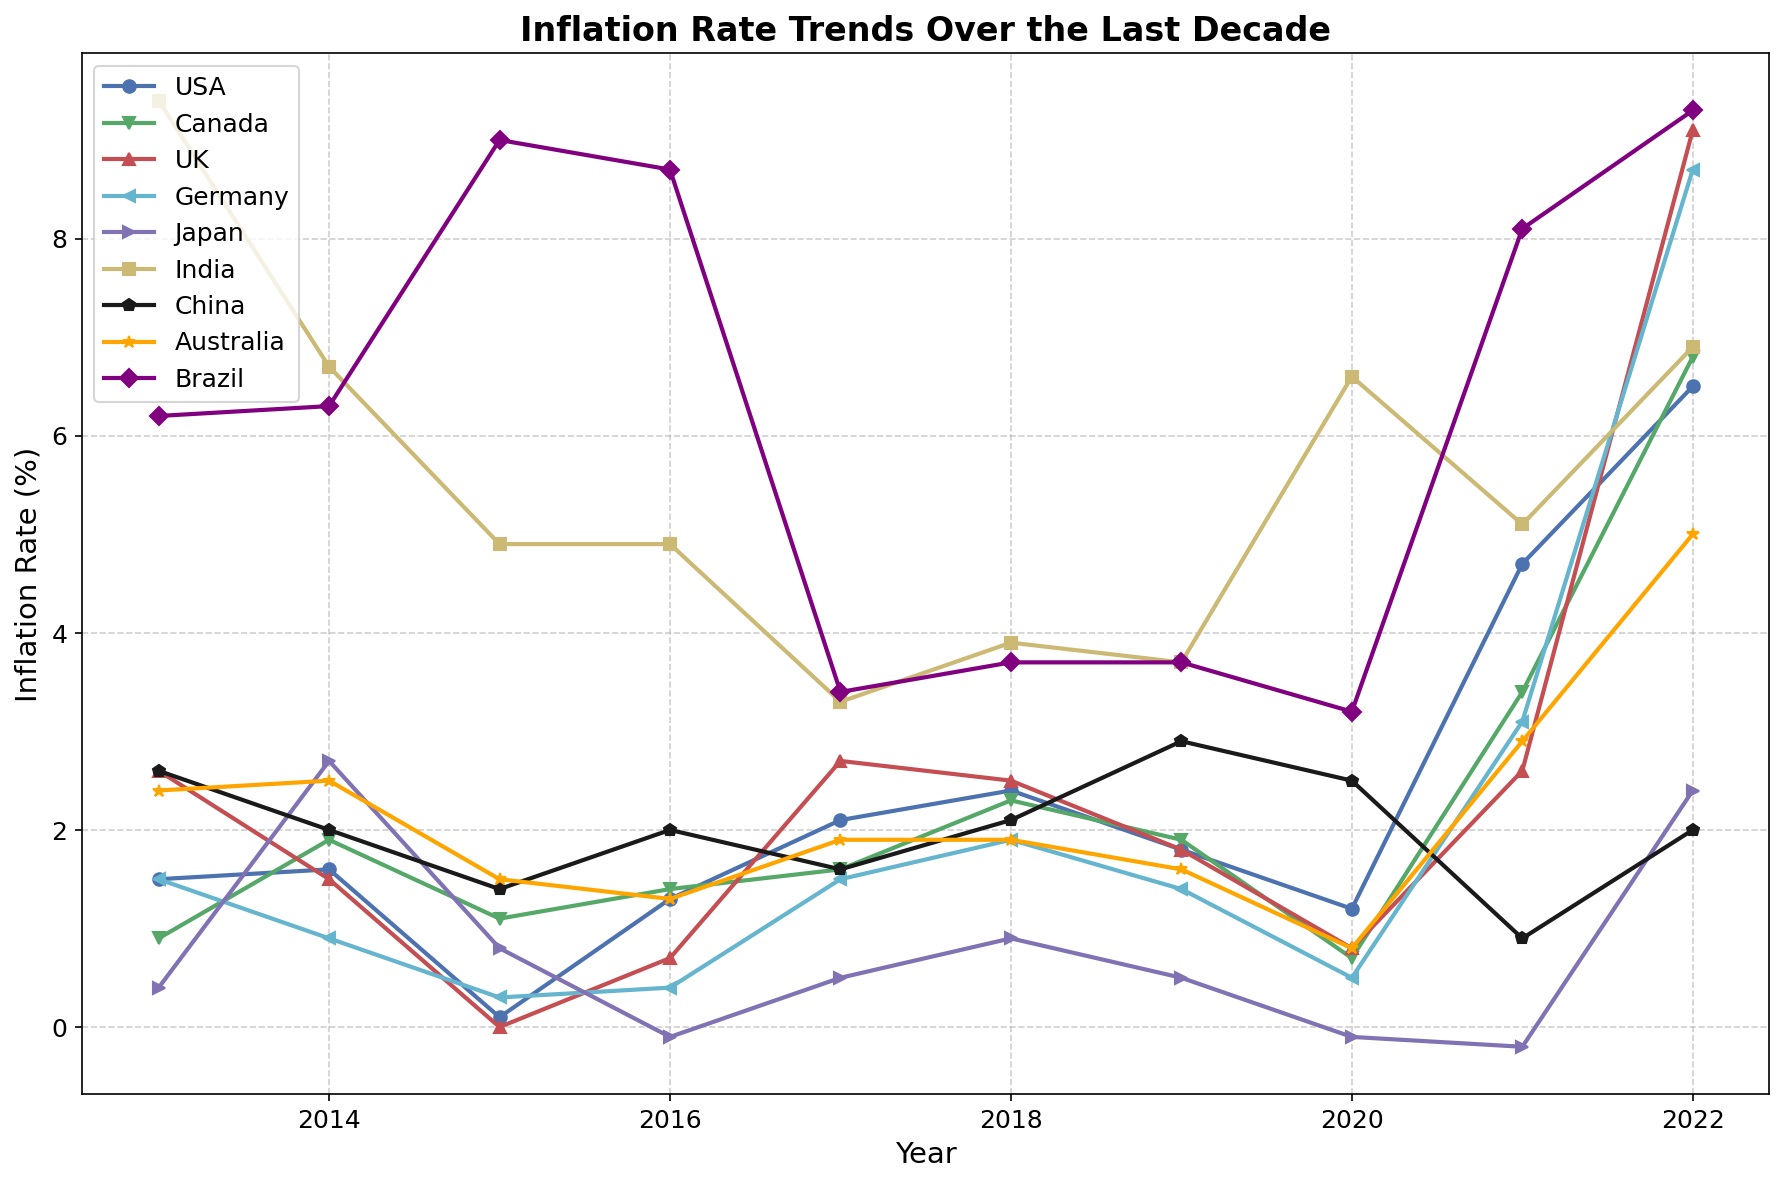What was the inflation rate of Germany in 2022? We look at the plot for the year 2022 and identify the line color and marker style representing Germany to find the value at that point.
Answer: 8.7% Which country experienced the highest inflation rate in 2022? Check the lines on the plot for 2022 and identify which country has the highest data point.
Answer: Brazil Between 2015 and 2016, what was the change in inflation rate for the UK? Identify the points corresponding to the UK for the years 2015 and 2016 and calculate their difference: 0.7 (2016) - 0.0 (2015)
Answer: 0.7% Which country saw a decrease in inflation rate between 2014 and 2015? Compare the values from 2014 to 2015 for each country and find which one decreased.
Answer: India What is the average inflation rate of Japan from 2013 to 2022? Sum up Japan's inflation rates for each year from 2013 to 2022 and then divide by 10: (0.4 + 2.7 + 0.8 - 0.1 + 0.5 + 0.9 + 0.5 - 0.1 - 0.2 + 2.4) / 10
Answer: 0.78% In which year did the USA have its lowest inflation rate? Look at each year’s inflation rate for the USA and identify the minimum value: 2015, value 0.1
Answer: 2015 Which two countries had an inflation rate of around 2% in 2014? Identify the countries at 2014 that have values close to 2% by looking at the plot.
Answer: USA, China Between Canada and the UK, which country had a higher inflation rate trend in the last five years? Compare the slopes of the lines for Canada and the UK from 2018 to 2022. The UK shows a more rapid increase.
Answer: UK Which country had the most stable inflation rate over the decade? Determine which country has the least fluctuation by visually assessing the relatively straight and horizontal lines on the plot.
Answer: Germany On which years did Brazil have significant inflation rate drops? Find the years on the plot where Brazil's line shows a sharp decline.
Answer: 2015-2016, 2016-2017 